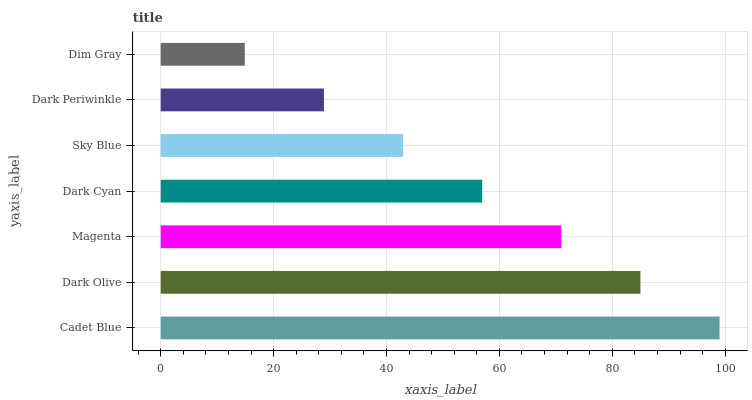Is Dim Gray the minimum?
Answer yes or no. Yes. Is Cadet Blue the maximum?
Answer yes or no. Yes. Is Dark Olive the minimum?
Answer yes or no. No. Is Dark Olive the maximum?
Answer yes or no. No. Is Cadet Blue greater than Dark Olive?
Answer yes or no. Yes. Is Dark Olive less than Cadet Blue?
Answer yes or no. Yes. Is Dark Olive greater than Cadet Blue?
Answer yes or no. No. Is Cadet Blue less than Dark Olive?
Answer yes or no. No. Is Dark Cyan the high median?
Answer yes or no. Yes. Is Dark Cyan the low median?
Answer yes or no. Yes. Is Magenta the high median?
Answer yes or no. No. Is Cadet Blue the low median?
Answer yes or no. No. 